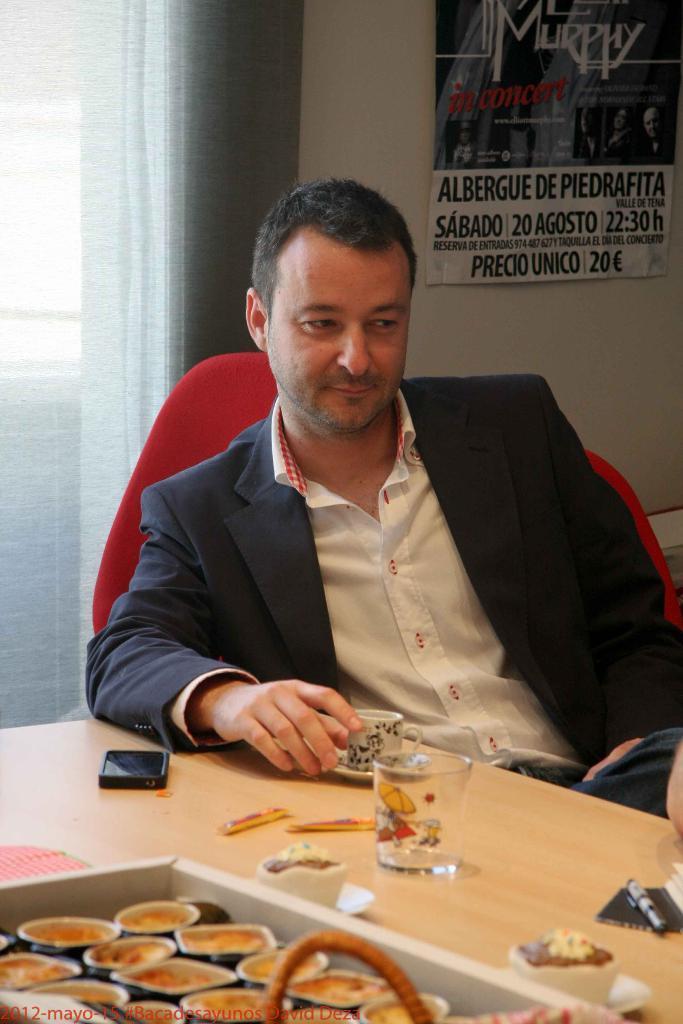Describe this image in one or two sentences. This is the picture of a room. In this image there is a person sitting and holding the cup. There is a glass, cell phone, pen and there are cups in the box and there are cups on the table. At the back there is a poster on the wall, In the poster there are two persons and there is a text. At the back there is a curtain. 